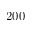<formula> <loc_0><loc_0><loc_500><loc_500>2 0 0</formula> 